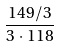<formula> <loc_0><loc_0><loc_500><loc_500>\frac { 1 4 9 / 3 } { 3 \cdot 1 1 8 }</formula> 